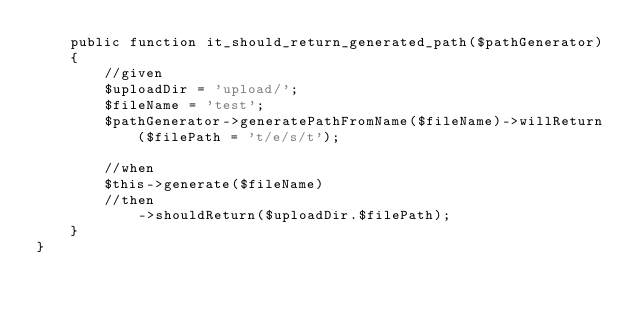<code> <loc_0><loc_0><loc_500><loc_500><_PHP_>    public function it_should_return_generated_path($pathGenerator)
    {
        //given
        $uploadDir = 'upload/';
        $fileName = 'test';
        $pathGenerator->generatePathFromName($fileName)->willReturn($filePath = 't/e/s/t');

        //when
        $this->generate($fileName)
        //then
            ->shouldReturn($uploadDir.$filePath);
    }
}
</code> 